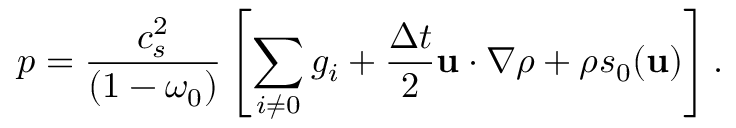<formula> <loc_0><loc_0><loc_500><loc_500>p = \frac { c _ { s } ^ { 2 } } { \left ( 1 - \omega _ { 0 } \right ) } \left [ \sum _ { i \neq 0 } g _ { i } + \frac { \Delta t } { 2 } u \cdot \nabla \rho + \rho s _ { 0 } ( u ) \right ] .</formula> 